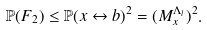Convert formula to latex. <formula><loc_0><loc_0><loc_500><loc_500>\mathbb { P } ( F _ { 2 } ) \leq \mathbb { P } ( x \leftrightarrow b ) ^ { 2 } = ( M _ { x } ^ { \Lambda _ { l } } ) ^ { 2 } .</formula> 